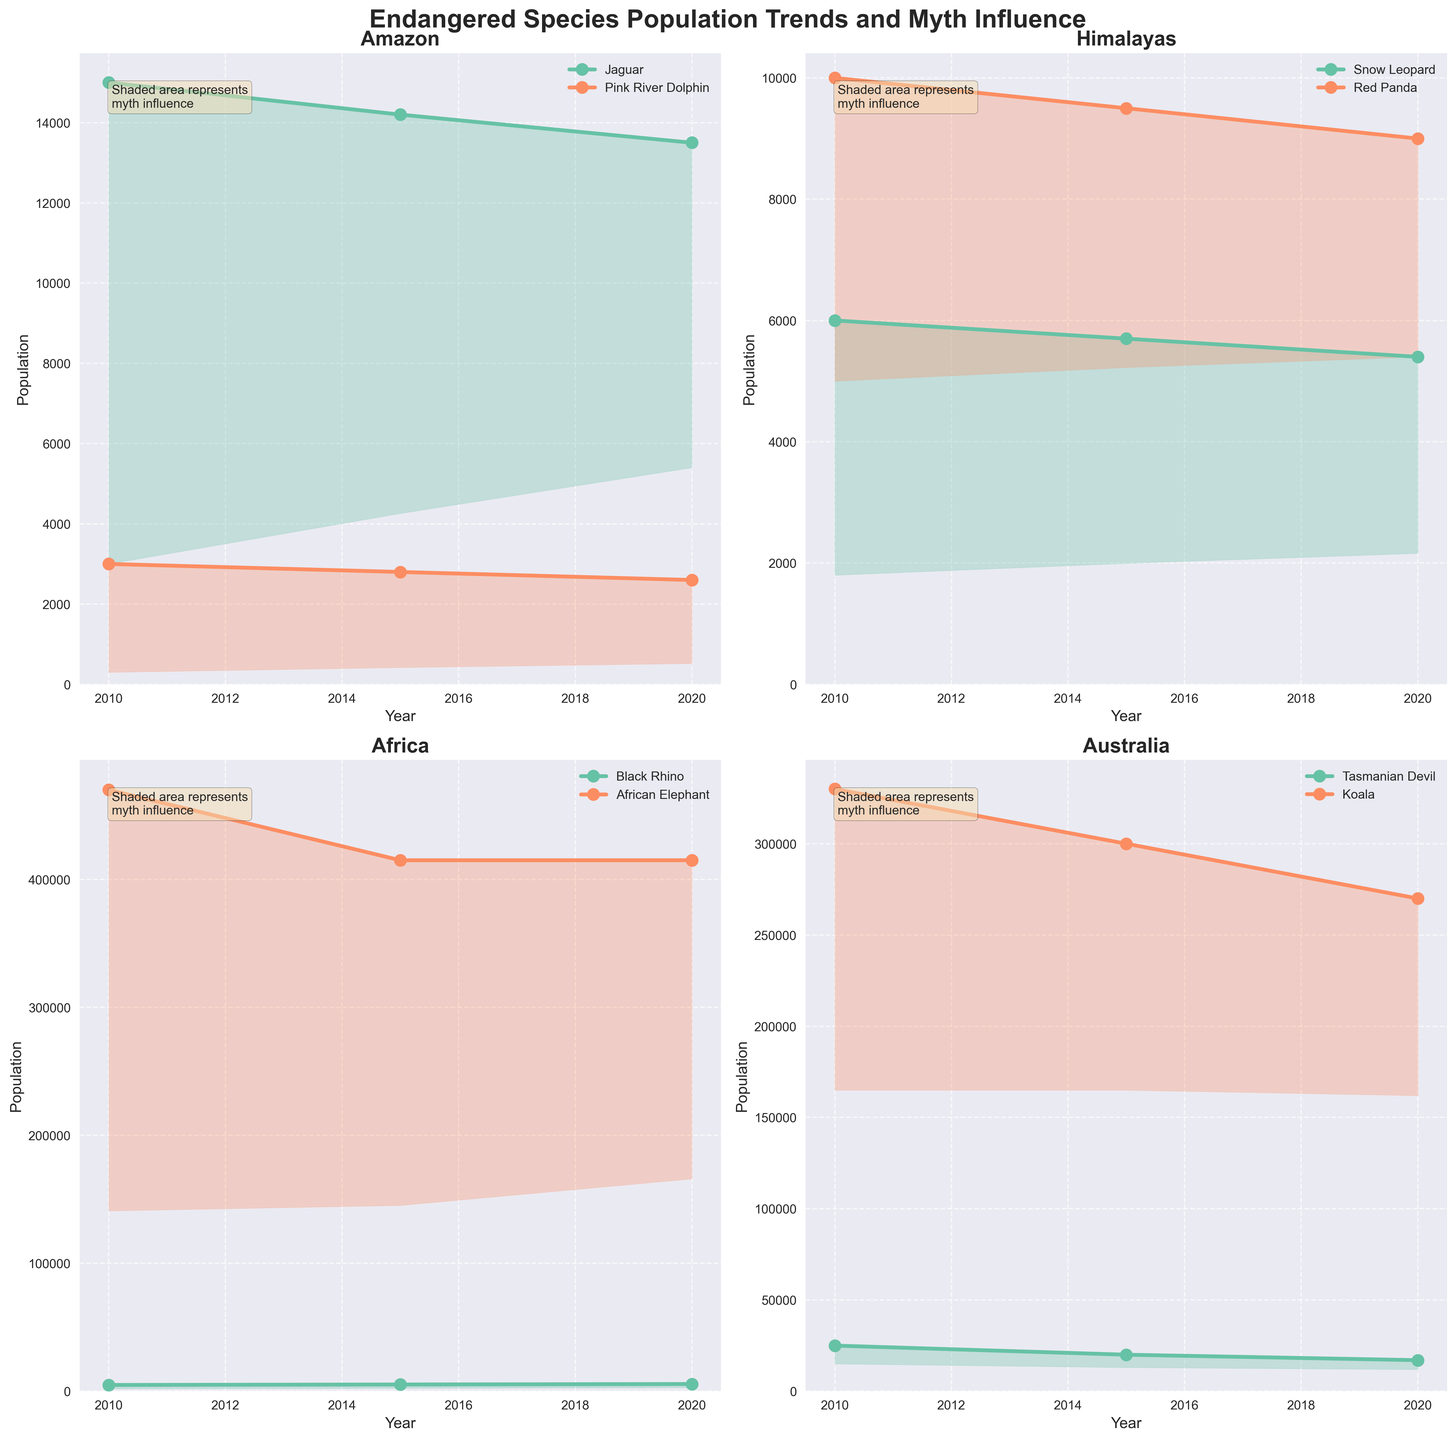How has the population trend for the Jaguar in the Amazon changed from 2010 to 2020? The population of the Jaguar in the Amazon decreased from 15000 in 2010 to 13500 in 2020.
Answer: Decreased Which species in the Himalayas has experienced a larger percentage decline in population from 2010 to 2020? The Snow Leopard's population decreased from 6000 to 5400, a 10% decline. The Red Panda's population declined from 10000 to 9000, a 10% decline. Thus, both species experienced an equal percentage decline.
Answer: Both In which region is the myth influence less impactful on the populations in 2020? Comparing the shaded areas, the myth influence is generally lower in Africa and Australia compared to the Amazon and the Himalayas.
Answer: Africa and Australia What is the difference in population between the Black Rhino and African Elephant in 2020? The population of the African Elephant is 415000 and the Black Rhino is 5630 in 2020. The difference is 415000 - 5630 = 409370.
Answer: 409370 Which species has had the most stable population in the last decade across all regions? The African Elephant population remained constant at 415000 from 2015 to 2020, depicting the most stability.
Answer: African Elephant Which species' population shows the steepest decline over the years in the figure? The Tasmanian Devil population in Australia decreased significantly from 25000 in 2010 to 17000 in 2020, a steep decline.
Answer: Tasmanian Devil Does the population trend of the Red Panda indicate a significant impact by myth influence when compared to others? The Red Panda shows a steady decline in population from 10000 in 2010 to 9000 in 2020 with a decreasing myth influence (0.5 to 0.4). The shaded area remains relatively small, indicating less impact by myth influence compared to others.
Answer: No Between the years 2010 and 2020, which region showed an overall positive growth in at least one species population and by how much? In Africa, the Black Rhino population grew from 4880 in 2010 to 5630 in 2020, indicating a positive growth of 5630 - 4880 = 750.
Answer: Africa, 750 